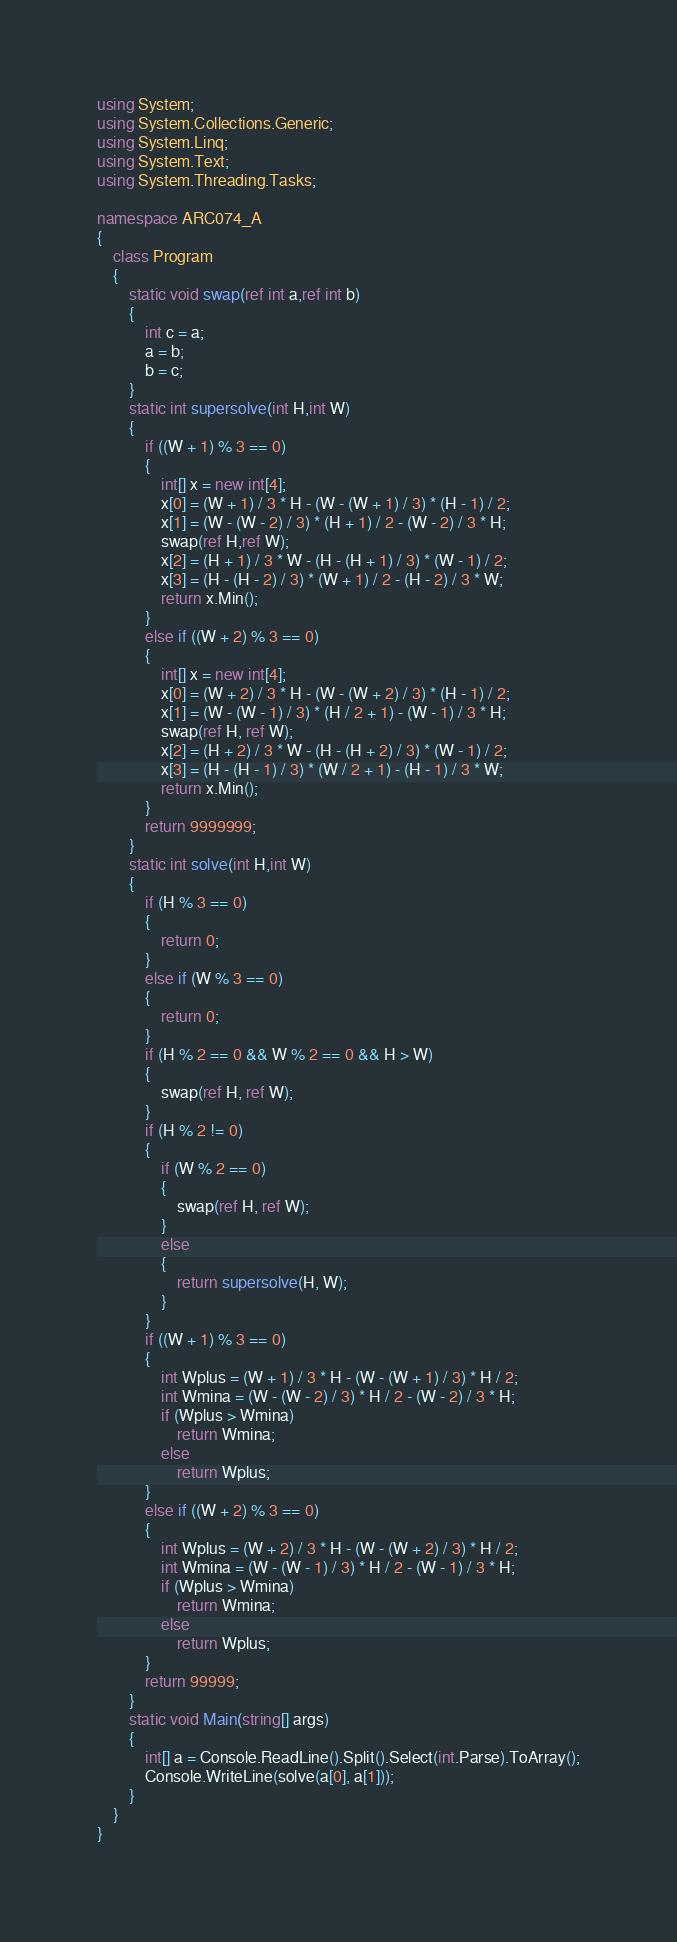<code> <loc_0><loc_0><loc_500><loc_500><_C#_>using System;
using System.Collections.Generic;
using System.Linq;
using System.Text;
using System.Threading.Tasks;

namespace ARC074_A
{
    class Program
    {
        static void swap(ref int a,ref int b)
        {
            int c = a;
            a = b;
            b = c;
        }
        static int supersolve(int H,int W)
        {
            if ((W + 1) % 3 == 0)
            {
                int[] x = new int[4];
                x[0] = (W + 1) / 3 * H - (W - (W + 1) / 3) * (H - 1) / 2;
                x[1] = (W - (W - 2) / 3) * (H + 1) / 2 - (W - 2) / 3 * H;
                swap(ref H,ref W);
                x[2] = (H + 1) / 3 * W - (H - (H + 1) / 3) * (W - 1) / 2;
                x[3] = (H - (H - 2) / 3) * (W + 1) / 2 - (H - 2) / 3 * W;
                return x.Min();
            }
            else if ((W + 2) % 3 == 0)
            {
                int[] x = new int[4];
                x[0] = (W + 2) / 3 * H - (W - (W + 2) / 3) * (H - 1) / 2;
                x[1] = (W - (W - 1) / 3) * (H / 2 + 1) - (W - 1) / 3 * H;
                swap(ref H, ref W);
                x[2] = (H + 2) / 3 * W - (H - (H + 2) / 3) * (W - 1) / 2;
                x[3] = (H - (H - 1) / 3) * (W / 2 + 1) - (H - 1) / 3 * W;
                return x.Min();
            }
            return 9999999;
        }
        static int solve(int H,int W)
        {
            if (H % 3 == 0)
            {
                return 0;
            }
            else if (W % 3 == 0)
            {
                return 0;
            }
            if (H % 2 == 0 && W % 2 == 0 && H > W)
            {
                swap(ref H, ref W);
            }
            if (H % 2 != 0)
            {
                if (W % 2 == 0)
                {
                    swap(ref H, ref W);
                }
                else
                {
                    return supersolve(H, W);
                }
            }
            if ((W + 1) % 3 == 0)
            {
                int Wplus = (W + 1) / 3 * H - (W - (W + 1) / 3) * H / 2;
                int Wmina = (W - (W - 2) / 3) * H / 2 - (W - 2) / 3 * H;
                if (Wplus > Wmina)
                    return Wmina;
                else
                    return Wplus;
            }
            else if ((W + 2) % 3 == 0)
            {
                int Wplus = (W + 2) / 3 * H - (W - (W + 2) / 3) * H / 2;
                int Wmina = (W - (W - 1) / 3) * H / 2 - (W - 1) / 3 * H;
                if (Wplus > Wmina)
                    return Wmina;
                else
                    return Wplus;
            }
            return 99999;
        }
        static void Main(string[] args)
        {
            int[] a = Console.ReadLine().Split().Select(int.Parse).ToArray();
            Console.WriteLine(solve(a[0], a[1]));
        }
    }
}
</code> 